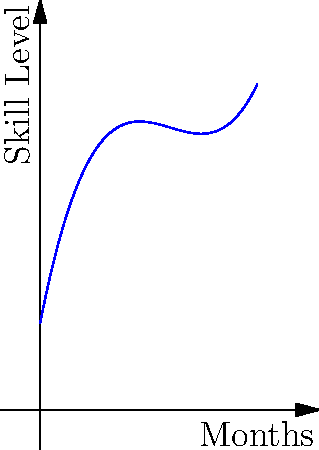A child's improvement in a specific occupational therapy skill is modeled using the polynomial regression equation $y = 0.2x^3 - 1.8x^2 + 5.1x + 2$, where $y$ represents the skill level and $x$ represents the number of months in therapy. Based on this model, what is the predicted skill level after 6 months of therapy? To find the predicted skill level after 6 months of therapy, we need to substitute $x = 6$ into the given polynomial equation:

$y = 0.2x^3 - 1.8x^2 + 5.1x + 2$

Step 1: Substitute $x = 6$
$y = 0.2(6)^3 - 1.8(6)^2 + 5.1(6) + 2$

Step 2: Calculate the powers
$y = 0.2(216) - 1.8(36) + 5.1(6) + 2$

Step 3: Multiply
$y = 43.2 - 64.8 + 30.6 + 2$

Step 4: Add and subtract
$y = 11$

Therefore, the predicted skill level after 6 months of therapy is 11.
Answer: 11 